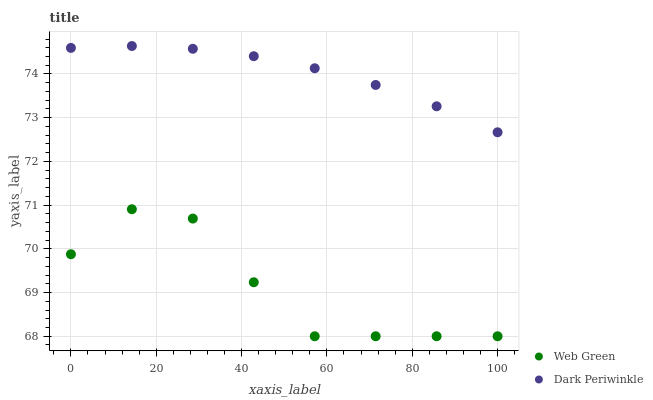Does Web Green have the minimum area under the curve?
Answer yes or no. Yes. Does Dark Periwinkle have the maximum area under the curve?
Answer yes or no. Yes. Does Web Green have the maximum area under the curve?
Answer yes or no. No. Is Dark Periwinkle the smoothest?
Answer yes or no. Yes. Is Web Green the roughest?
Answer yes or no. Yes. Is Web Green the smoothest?
Answer yes or no. No. Does Web Green have the lowest value?
Answer yes or no. Yes. Does Dark Periwinkle have the highest value?
Answer yes or no. Yes. Does Web Green have the highest value?
Answer yes or no. No. Is Web Green less than Dark Periwinkle?
Answer yes or no. Yes. Is Dark Periwinkle greater than Web Green?
Answer yes or no. Yes. Does Web Green intersect Dark Periwinkle?
Answer yes or no. No. 